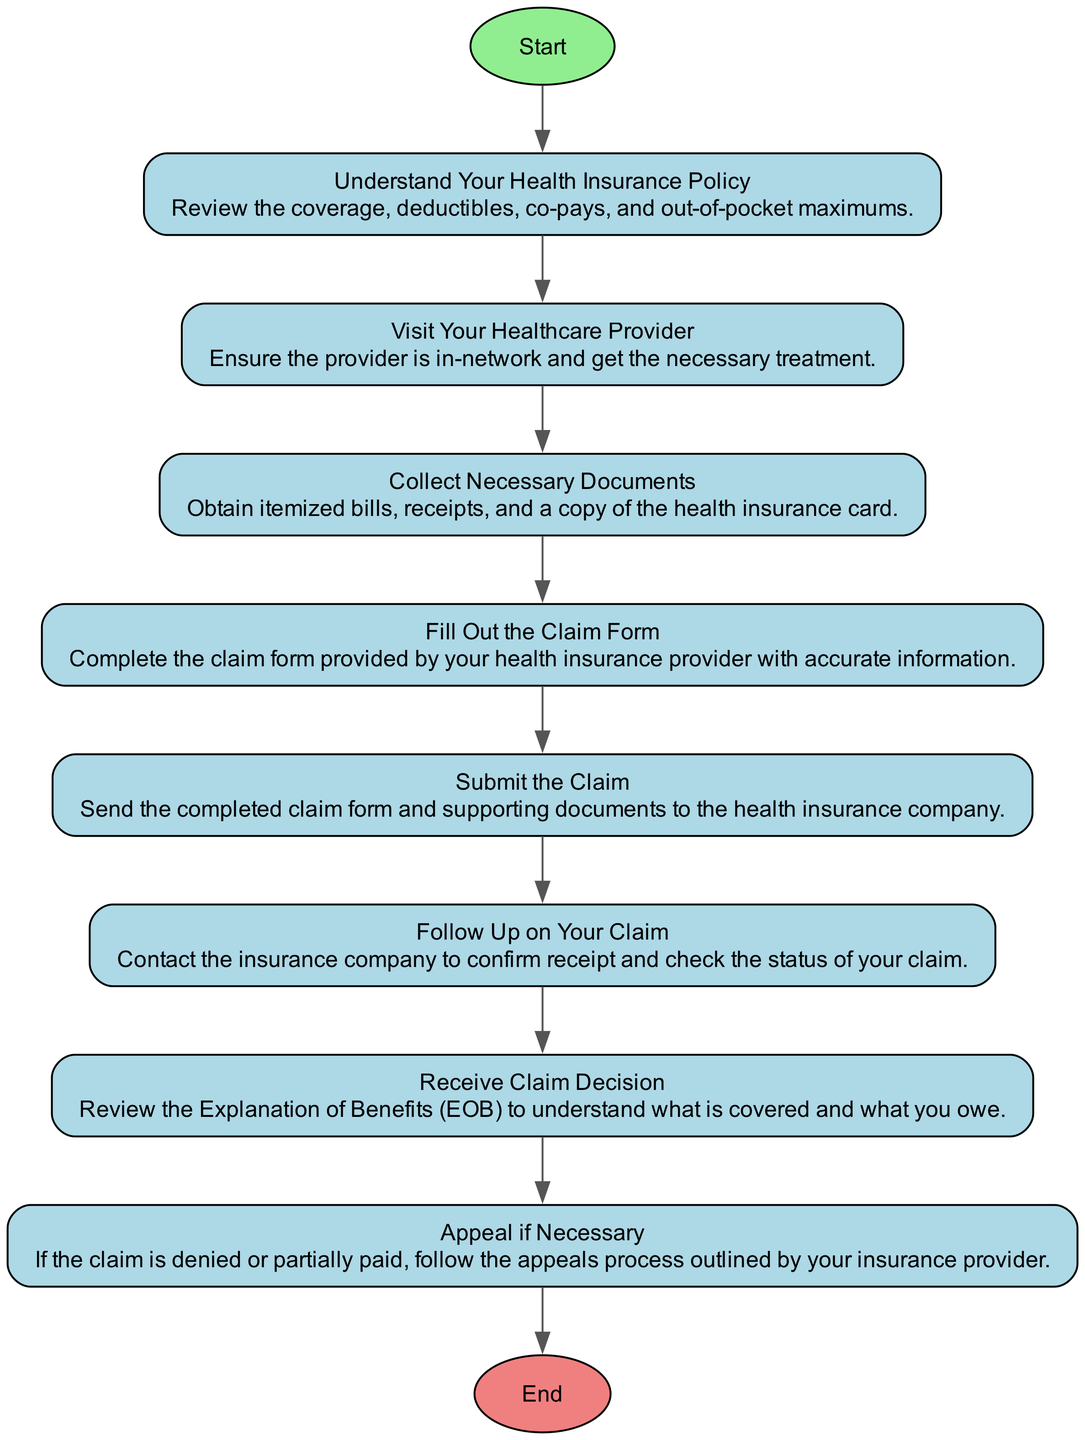What is the first step to file a health insurance claim? The first step shown in the diagram is "Understand Your Health Insurance Policy." This is indicated as the first action before progressing to other steps.
Answer: Understand Your Health Insurance Policy How many steps are there to file a health insurance claim? By reviewing the diagram, there are a total of eight steps listed. Each step is represented in a sequence leading up to the claim process completion.
Answer: Eight Which step involves collecting documents? The step that involves collecting documents is "Collect Necessary Documents." This action is listed as Step 3 in the diagram, explicitly detailing what to gather for filing a claim.
Answer: Collect Necessary Documents What is the action taken after submitting the claim? After submitting the claim, the next action indicated in the flowchart is "Follow Up on Your Claim." This step ensures the status of the claim is checked after submission.
Answer: Follow Up on Your Claim What color is used for the start node in the diagram? The start node in the diagram is filled with light green color, visually distinguishing it from other nodes in the flowchart.
Answer: Light green What is the purpose of the "Appeal if Necessary" step? The purpose of the "Appeal if Necessary" step is to address situations where a claim is denied or partially paid, directing the person to follow the outlined appeals process by the insurance provider.
Answer: To appeal a denied or partially paid claim How does the diagram indicate that the process ends? The diagram indicates that the process ends with the "End" node, which is connected from the last step. The end node is colored light coral to signify that the process has concluded.
Answer: End How many actions are performed before receiving the claim decision? There are six actions performed before receiving the claim decision. They include understanding the policy, visiting the provider, collecting documents, filling out the form, submitting the claim, and following up.
Answer: Six 